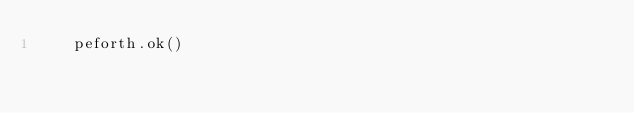<code> <loc_0><loc_0><loc_500><loc_500><_Python_>    peforth.ok()
</code> 